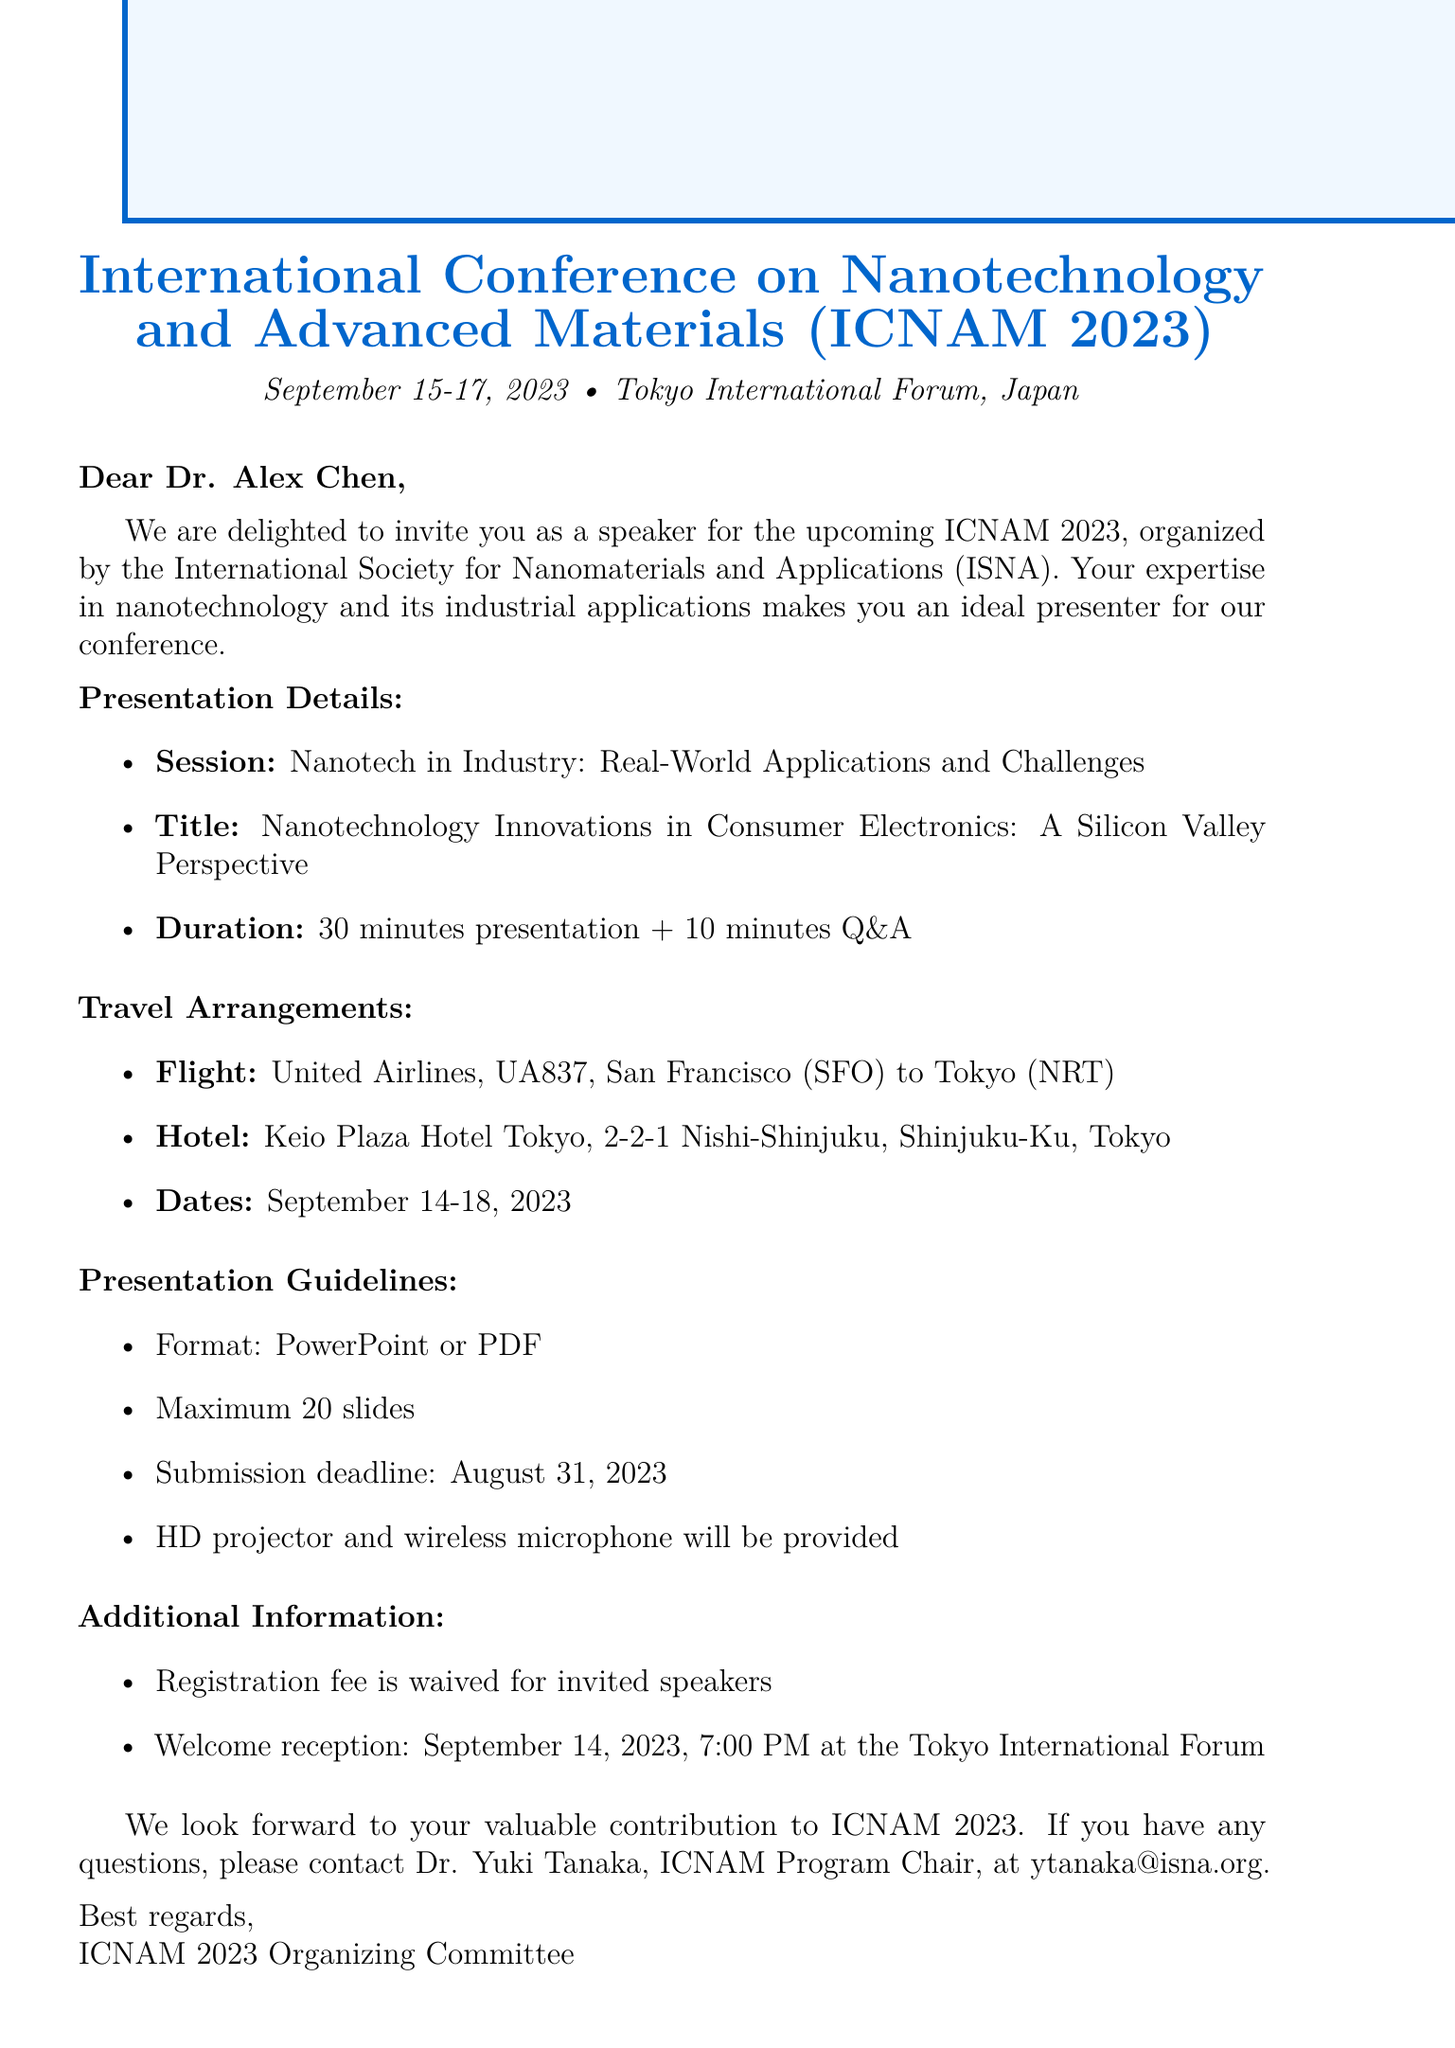What are the dates of the conference? The dates of the conference are specified as September 15-17, 2023.
Answer: September 15-17, 2023 Who is the invited speaker? The document states that the invited speaker is Dr. Alex Chen.
Answer: Dr. Alex Chen What is the presentation title? The title of the presentation is provided as "Nanotechnology Innovations in Consumer Electronics: A Silicon Valley Perspective."
Answer: Nanotechnology Innovations in Consumer Electronics: A Silicon Valley Perspective What is the hotel name for accommodation? The hotel for accommodation is mentioned as Keio Plaza Hotel Tokyo.
Answer: Keio Plaza Hotel Tokyo When is the submission deadline for the presentation? The deadline for submitting the presentation is indicated as August 31, 2023.
Answer: August 31, 2023 What equipment will be provided for the presentation? The document states that an HD projector and wireless microphone will be provided for the presentation.
Answer: HD projector and wireless microphone What is waived for invited speakers? The registration fee is waived for invited speakers, as confirmed in the additional information section.
Answer: Registration fee What session will the speaker present in? The session outlined for the presentation is "Nanotech in Industry: Real-World Applications and Challenges."
Answer: Nanotech in Industry: Real-World Applications and Challenges What time is the welcome reception? The welcome reception is scheduled for September 14, 2023, at 7:00 PM.
Answer: 7:00 PM 